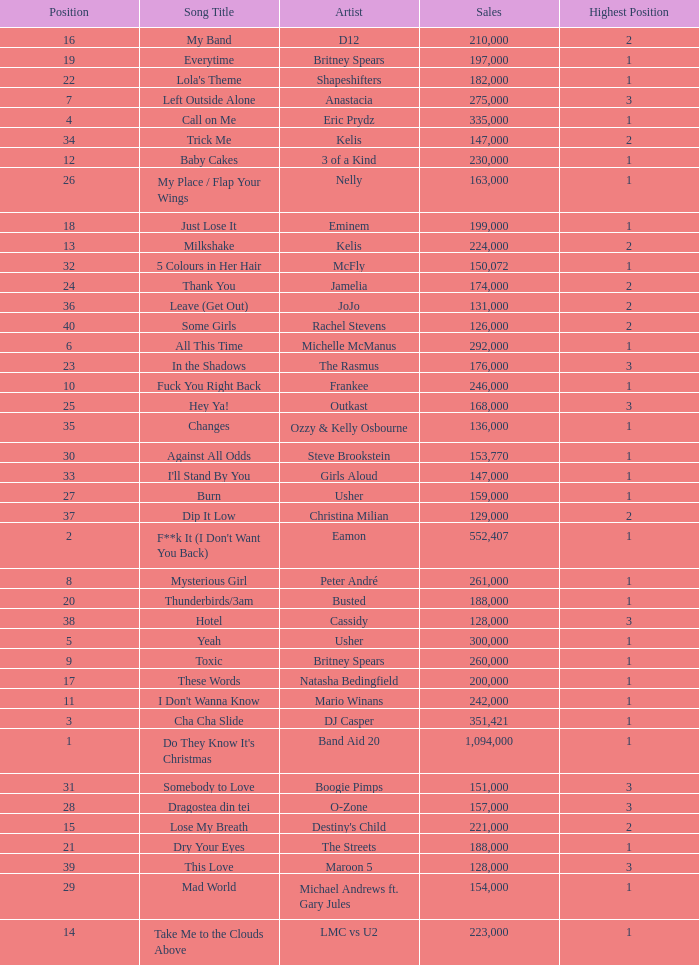What were the sales for Dj Casper when he was in a position lower than 13? 351421.0. 